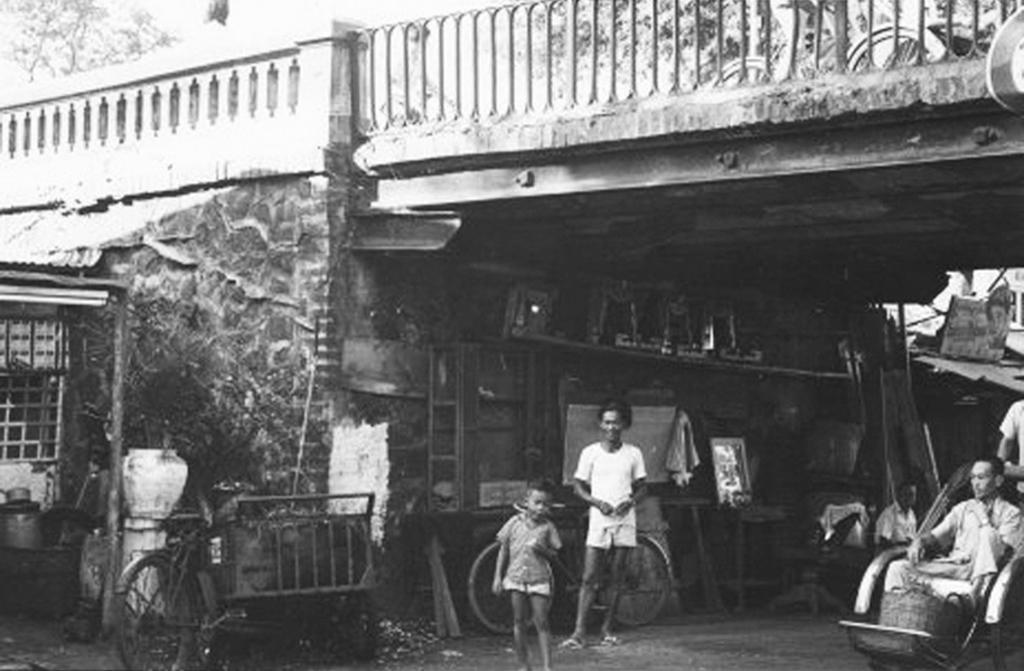Describe this image in one or two sentences. In this image there are people. On the right we can see a man sitting. On the left there is a shed. We can see bicycles. At the top there is a bridge. In the background there are trees. 